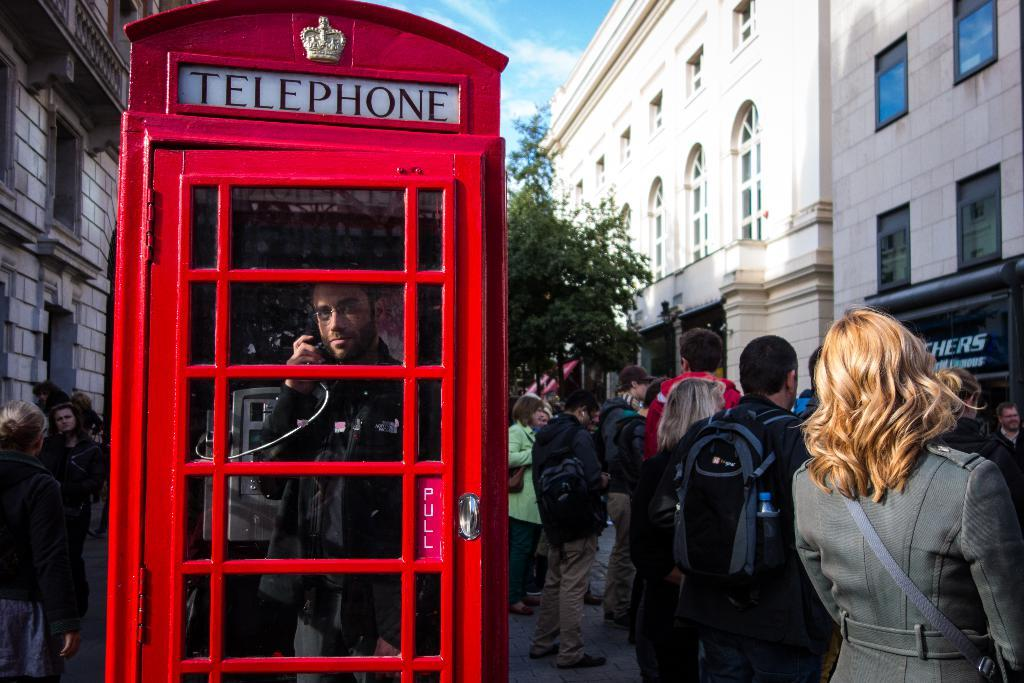Provide a one-sentence caption for the provided image. On a crowded street, a man talks on the phone inside a red booth labeled TELEPHONE. 